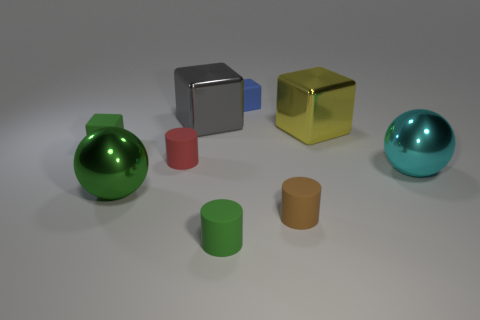There is another tiny rubber thing that is the same shape as the blue thing; what is its color?
Give a very brief answer. Green. Are the small cylinder that is to the right of the blue object and the large object on the right side of the yellow block made of the same material?
Ensure brevity in your answer.  No. What is the shape of the green object that is in front of the tiny red cylinder and left of the gray object?
Provide a short and direct response. Sphere. What number of small cyan spheres are there?
Your response must be concise. 0. There is another metal thing that is the same shape as the green metallic thing; what size is it?
Give a very brief answer. Large. There is a small green object in front of the brown object; is it the same shape as the tiny blue matte object?
Your response must be concise. No. What is the color of the tiny rubber cube behind the large yellow object?
Make the answer very short. Blue. How many other objects are the same size as the brown rubber cylinder?
Offer a very short reply. 4. Are there the same number of red rubber cylinders behind the yellow metal block and large purple spheres?
Provide a short and direct response. Yes. What number of blue cubes have the same material as the red object?
Offer a terse response. 1. 